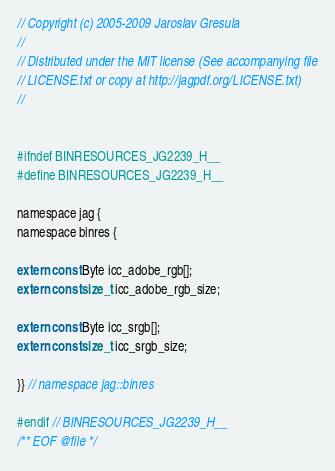<code> <loc_0><loc_0><loc_500><loc_500><_C_>// Copyright (c) 2005-2009 Jaroslav Gresula
//
// Distributed under the MIT license (See accompanying file
// LICENSE.txt or copy at http://jagpdf.org/LICENSE.txt)
//


#ifndef BINRESOURCES_JG2239_H__
#define BINRESOURCES_JG2239_H__

namespace jag {
namespace binres {

extern const Byte icc_adobe_rgb[];
extern const size_t icc_adobe_rgb_size;

extern const Byte icc_srgb[];
extern const size_t icc_srgb_size;

}} // namespace jag::binres

#endif // BINRESOURCES_JG2239_H__
/** EOF @file */
</code> 